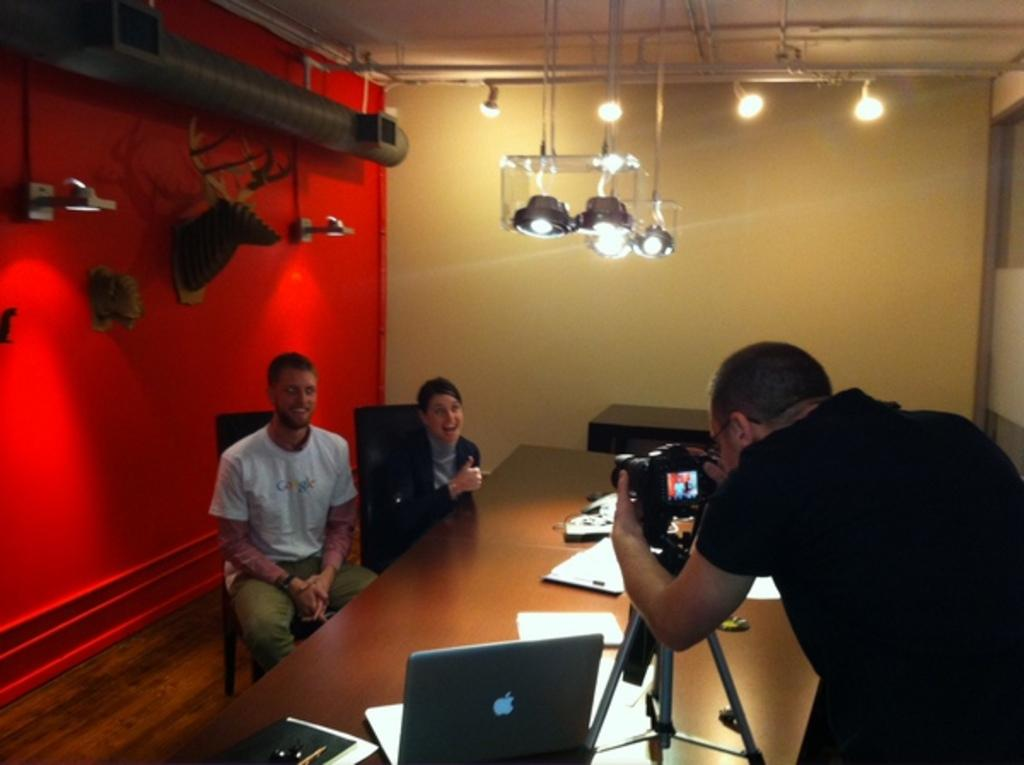What is the person in the image doing? The person is taking a photo. Who is the person taking a photo of? There are two people sitting in front of whom the person is taking a photo of. What can be seen on the table in the image? There is a laptop and papers on the table. What is the color of the wall in the background? There is a red wall in the background. What type of education can be seen in the image? There is no indication of education in the image; it features a person taking a photo of two people sitting in front of them, with a laptop and papers on the table, and a red wall in the background. 